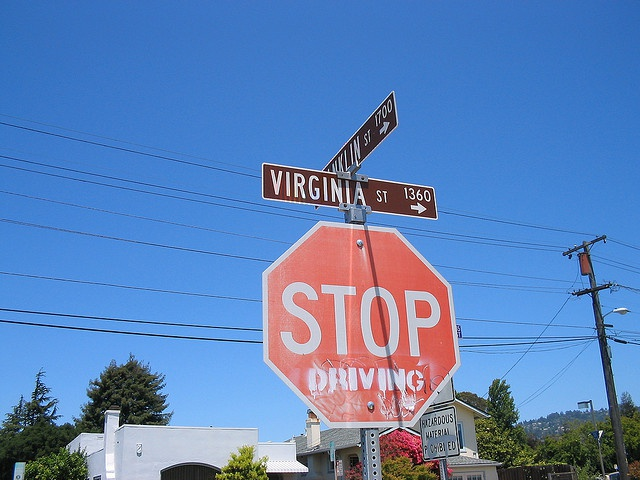Describe the objects in this image and their specific colors. I can see a stop sign in blue, salmon, and lightgray tones in this image. 